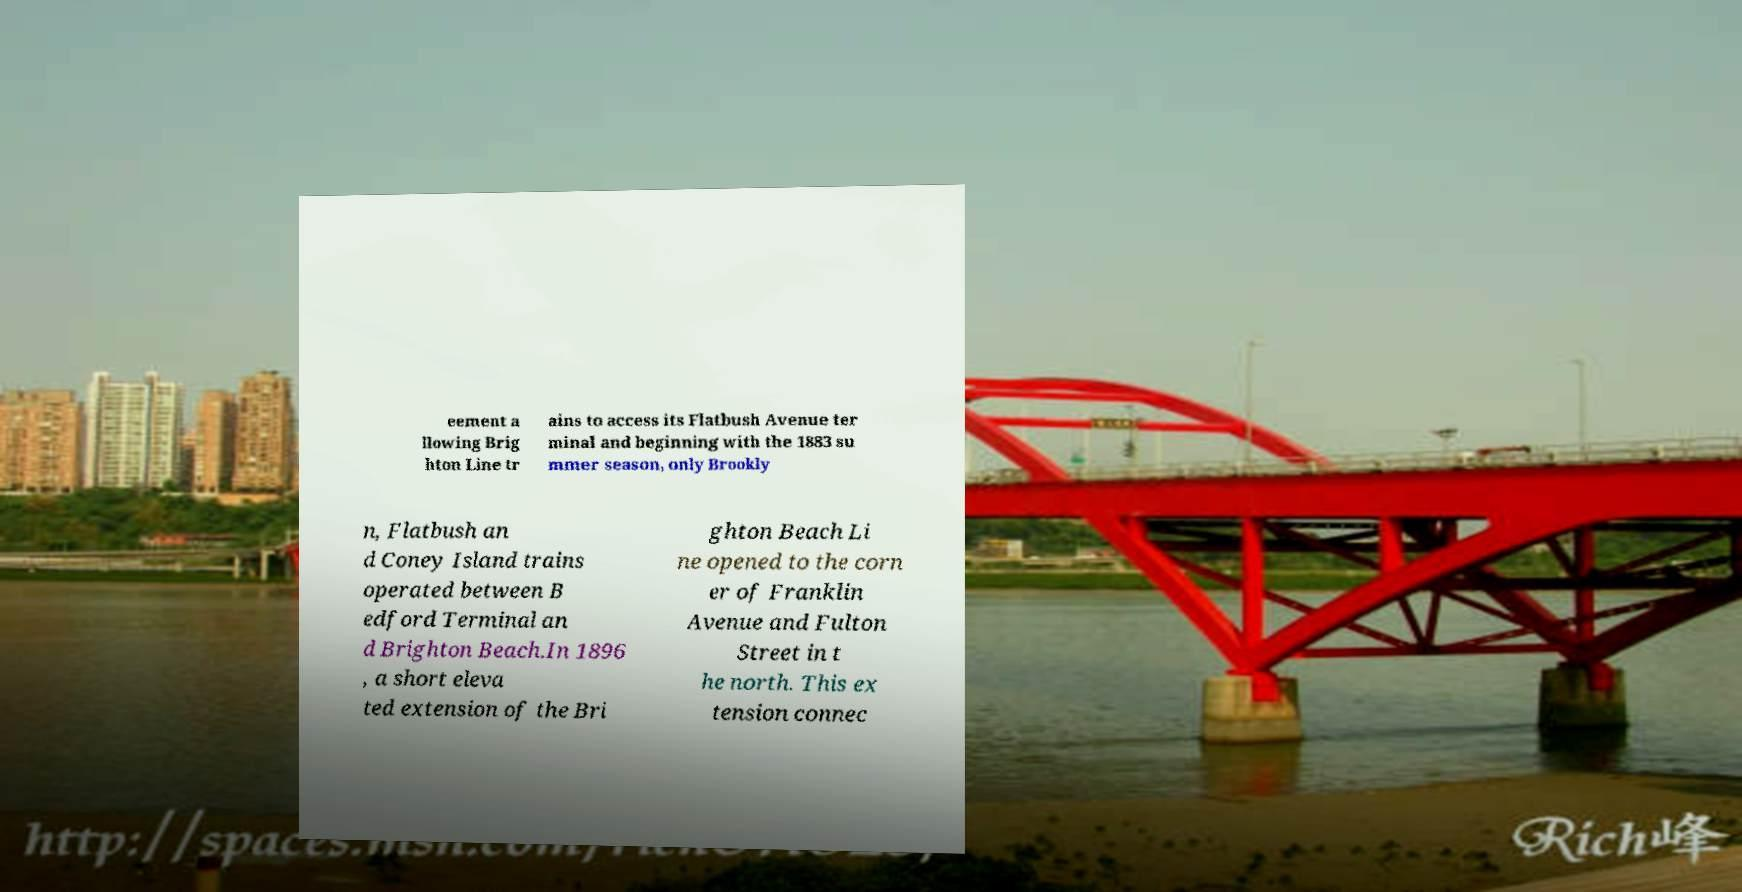Can you accurately transcribe the text from the provided image for me? eement a llowing Brig hton Line tr ains to access its Flatbush Avenue ter minal and beginning with the 1883 su mmer season, only Brookly n, Flatbush an d Coney Island trains operated between B edford Terminal an d Brighton Beach.In 1896 , a short eleva ted extension of the Bri ghton Beach Li ne opened to the corn er of Franklin Avenue and Fulton Street in t he north. This ex tension connec 